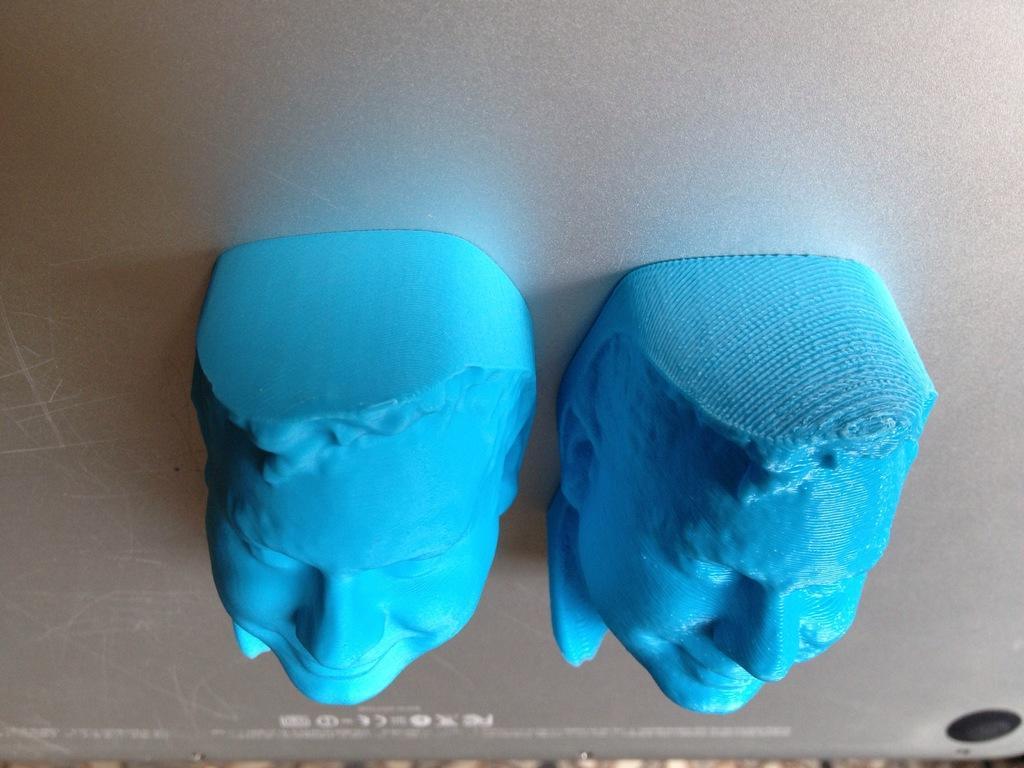Can you describe this image briefly? In the foreground of this image, there are two rubber faces and it seems like they are on a mobile phone. 